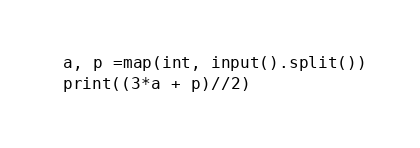<code> <loc_0><loc_0><loc_500><loc_500><_Python_>a, p =map(int, input().split())
print((3*a + p)//2)</code> 